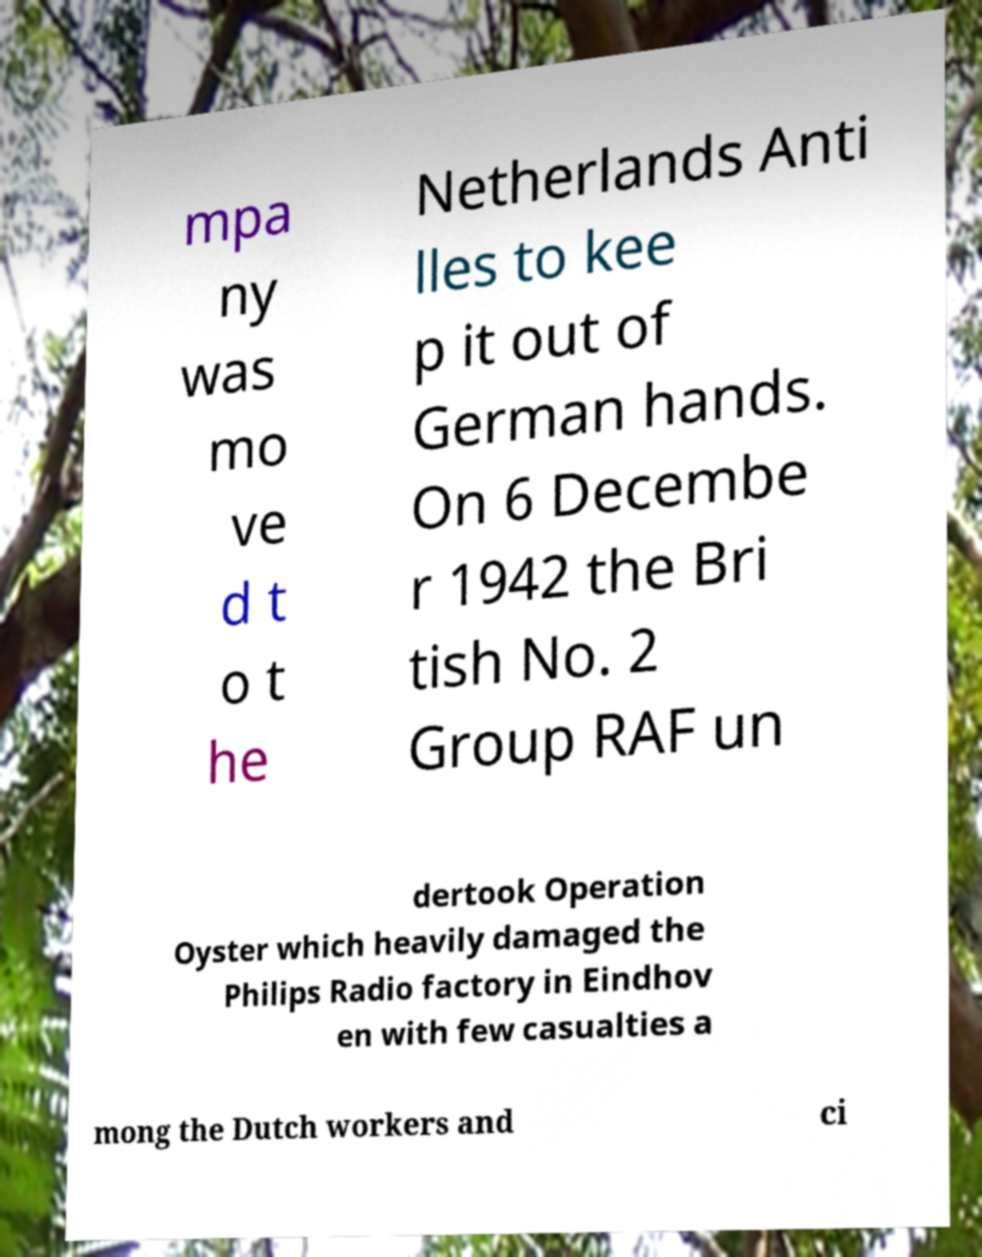Can you accurately transcribe the text from the provided image for me? mpa ny was mo ve d t o t he Netherlands Anti lles to kee p it out of German hands. On 6 Decembe r 1942 the Bri tish No. 2 Group RAF un dertook Operation Oyster which heavily damaged the Philips Radio factory in Eindhov en with few casualties a mong the Dutch workers and ci 